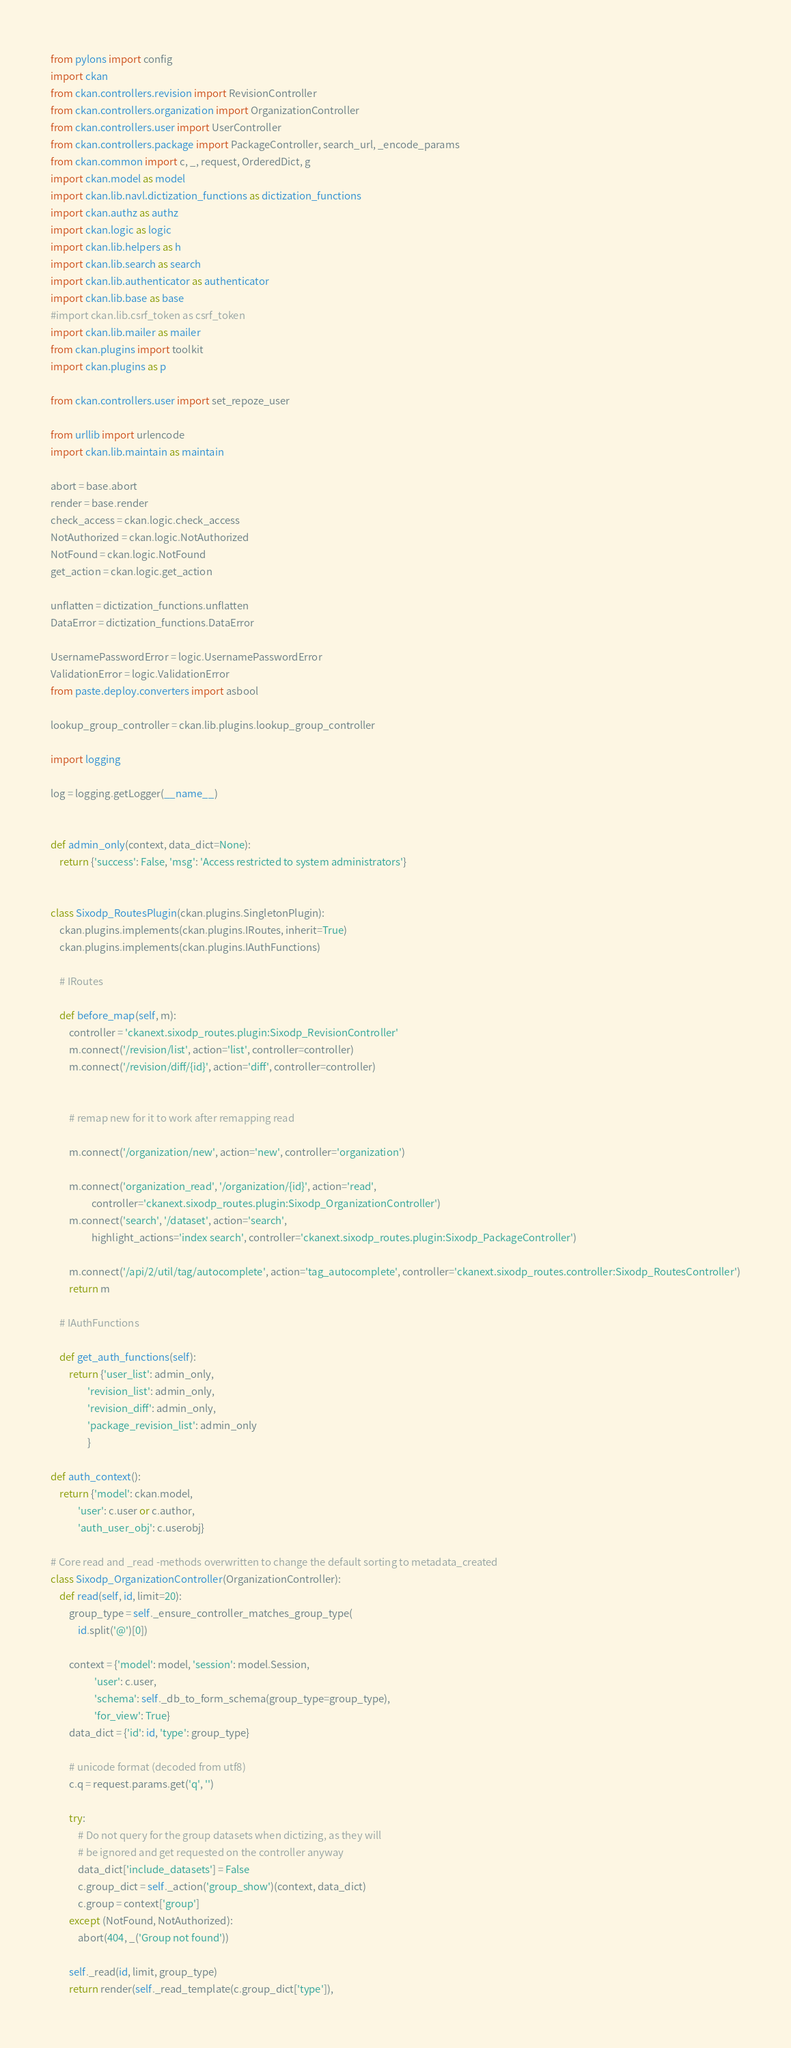Convert code to text. <code><loc_0><loc_0><loc_500><loc_500><_Python_>from pylons import config
import ckan
from ckan.controllers.revision import RevisionController
from ckan.controllers.organization import OrganizationController
from ckan.controllers.user import UserController
from ckan.controllers.package import PackageController, search_url, _encode_params
from ckan.common import c, _, request, OrderedDict, g
import ckan.model as model
import ckan.lib.navl.dictization_functions as dictization_functions
import ckan.authz as authz
import ckan.logic as logic
import ckan.lib.helpers as h
import ckan.lib.search as search
import ckan.lib.authenticator as authenticator
import ckan.lib.base as base
#import ckan.lib.csrf_token as csrf_token
import ckan.lib.mailer as mailer
from ckan.plugins import toolkit
import ckan.plugins as p

from ckan.controllers.user import set_repoze_user

from urllib import urlencode
import ckan.lib.maintain as maintain

abort = base.abort
render = base.render
check_access = ckan.logic.check_access
NotAuthorized = ckan.logic.NotAuthorized
NotFound = ckan.logic.NotFound
get_action = ckan.logic.get_action

unflatten = dictization_functions.unflatten
DataError = dictization_functions.DataError

UsernamePasswordError = logic.UsernamePasswordError
ValidationError = logic.ValidationError
from paste.deploy.converters import asbool

lookup_group_controller = ckan.lib.plugins.lookup_group_controller

import logging

log = logging.getLogger(__name__)


def admin_only(context, data_dict=None):
    return {'success': False, 'msg': 'Access restricted to system administrators'}


class Sixodp_RoutesPlugin(ckan.plugins.SingletonPlugin):
    ckan.plugins.implements(ckan.plugins.IRoutes, inherit=True)
    ckan.plugins.implements(ckan.plugins.IAuthFunctions)

    # IRoutes

    def before_map(self, m):
        controller = 'ckanext.sixodp_routes.plugin:Sixodp_RevisionController'
        m.connect('/revision/list', action='list', controller=controller)
        m.connect('/revision/diff/{id}', action='diff', controller=controller)


        # remap new for it to work after remapping read

        m.connect('/organization/new', action='new', controller='organization')

        m.connect('organization_read', '/organization/{id}', action='read',
                  controller='ckanext.sixodp_routes.plugin:Sixodp_OrganizationController')
        m.connect('search', '/dataset', action='search',
                  highlight_actions='index search', controller='ckanext.sixodp_routes.plugin:Sixodp_PackageController')

        m.connect('/api/2/util/tag/autocomplete', action='tag_autocomplete', controller='ckanext.sixodp_routes.controller:Sixodp_RoutesController')
        return m

    # IAuthFunctions

    def get_auth_functions(self):
        return {'user_list': admin_only,
                'revision_list': admin_only,
                'revision_diff': admin_only,
                'package_revision_list': admin_only
                }

def auth_context():
    return {'model': ckan.model,
            'user': c.user or c.author,
            'auth_user_obj': c.userobj}

# Core read and _read -methods overwritten to change the default sorting to metadata_created
class Sixodp_OrganizationController(OrganizationController):
    def read(self, id, limit=20):
        group_type = self._ensure_controller_matches_group_type(
            id.split('@')[0])

        context = {'model': model, 'session': model.Session,
                   'user': c.user,
                   'schema': self._db_to_form_schema(group_type=group_type),
                   'for_view': True}
        data_dict = {'id': id, 'type': group_type}

        # unicode format (decoded from utf8)
        c.q = request.params.get('q', '')

        try:
            # Do not query for the group datasets when dictizing, as they will
            # be ignored and get requested on the controller anyway
            data_dict['include_datasets'] = False
            c.group_dict = self._action('group_show')(context, data_dict)
            c.group = context['group']
        except (NotFound, NotAuthorized):
            abort(404, _('Group not found'))

        self._read(id, limit, group_type)
        return render(self._read_template(c.group_dict['type']),</code> 